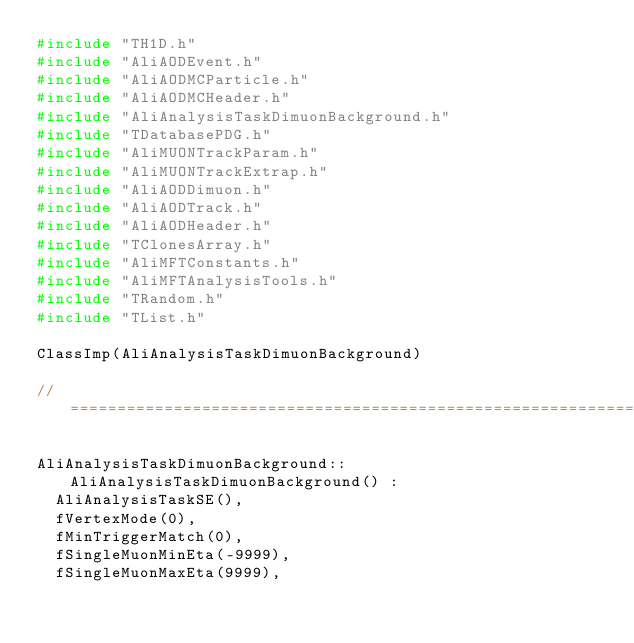Convert code to text. <code><loc_0><loc_0><loc_500><loc_500><_C++_>#include "TH1D.h"
#include "AliAODEvent.h"
#include "AliAODMCParticle.h"
#include "AliAODMCHeader.h"
#include "AliAnalysisTaskDimuonBackground.h"
#include "TDatabasePDG.h"
#include "AliMUONTrackParam.h"
#include "AliMUONTrackExtrap.h"
#include "AliAODDimuon.h"
#include "AliAODTrack.h"
#include "AliAODHeader.h"
#include "TClonesArray.h"
#include "AliMFTConstants.h"
#include "AliMFTAnalysisTools.h"
#include "TRandom.h"
#include "TList.h"

ClassImp(AliAnalysisTaskDimuonBackground)

//====================================================================================================================================================

AliAnalysisTaskDimuonBackground::AliAnalysisTaskDimuonBackground() : 
  AliAnalysisTaskSE(),
  fVertexMode(0),
  fMinTriggerMatch(0),
  fSingleMuonMinEta(-9999), 
  fSingleMuonMaxEta(9999), </code> 